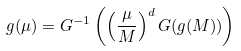Convert formula to latex. <formula><loc_0><loc_0><loc_500><loc_500>g ( \mu ) = G ^ { - 1 } \left ( \left ( { \frac { \mu } { M } } \right ) ^ { d } G ( g ( M ) ) \right )</formula> 